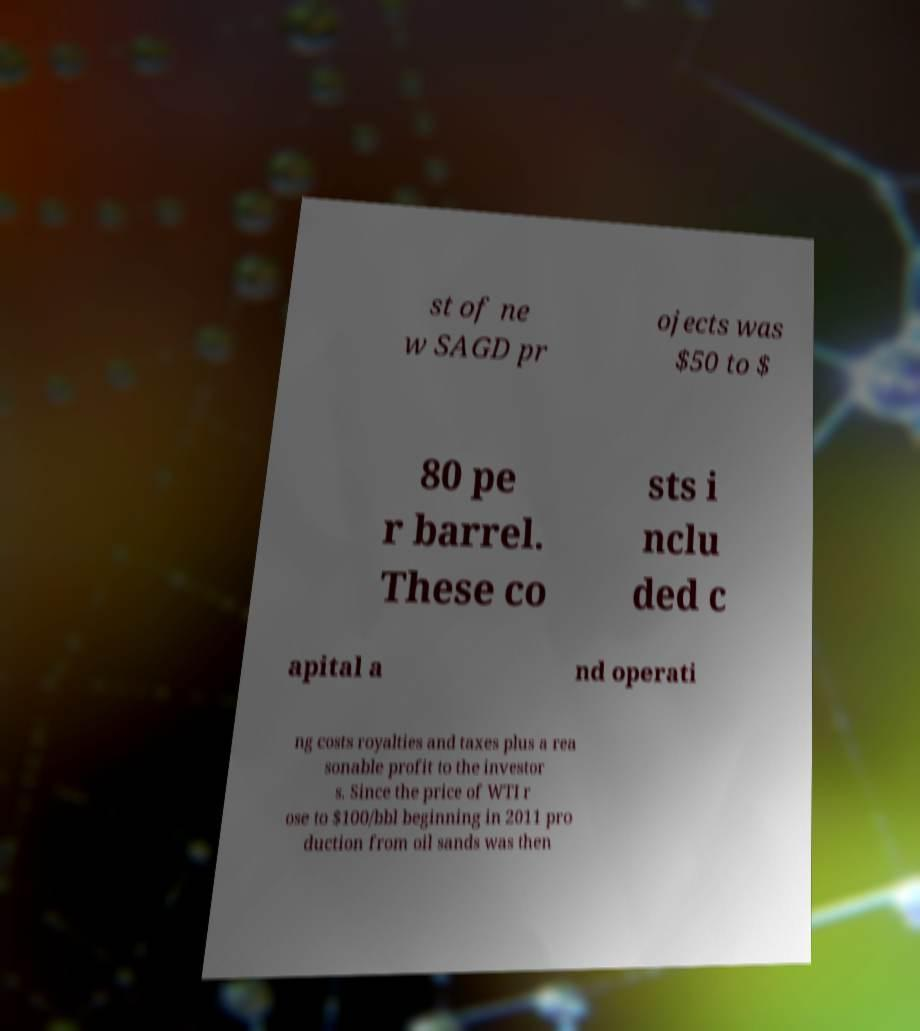Can you accurately transcribe the text from the provided image for me? st of ne w SAGD pr ojects was $50 to $ 80 pe r barrel. These co sts i nclu ded c apital a nd operati ng costs royalties and taxes plus a rea sonable profit to the investor s. Since the price of WTI r ose to $100/bbl beginning in 2011 pro duction from oil sands was then 